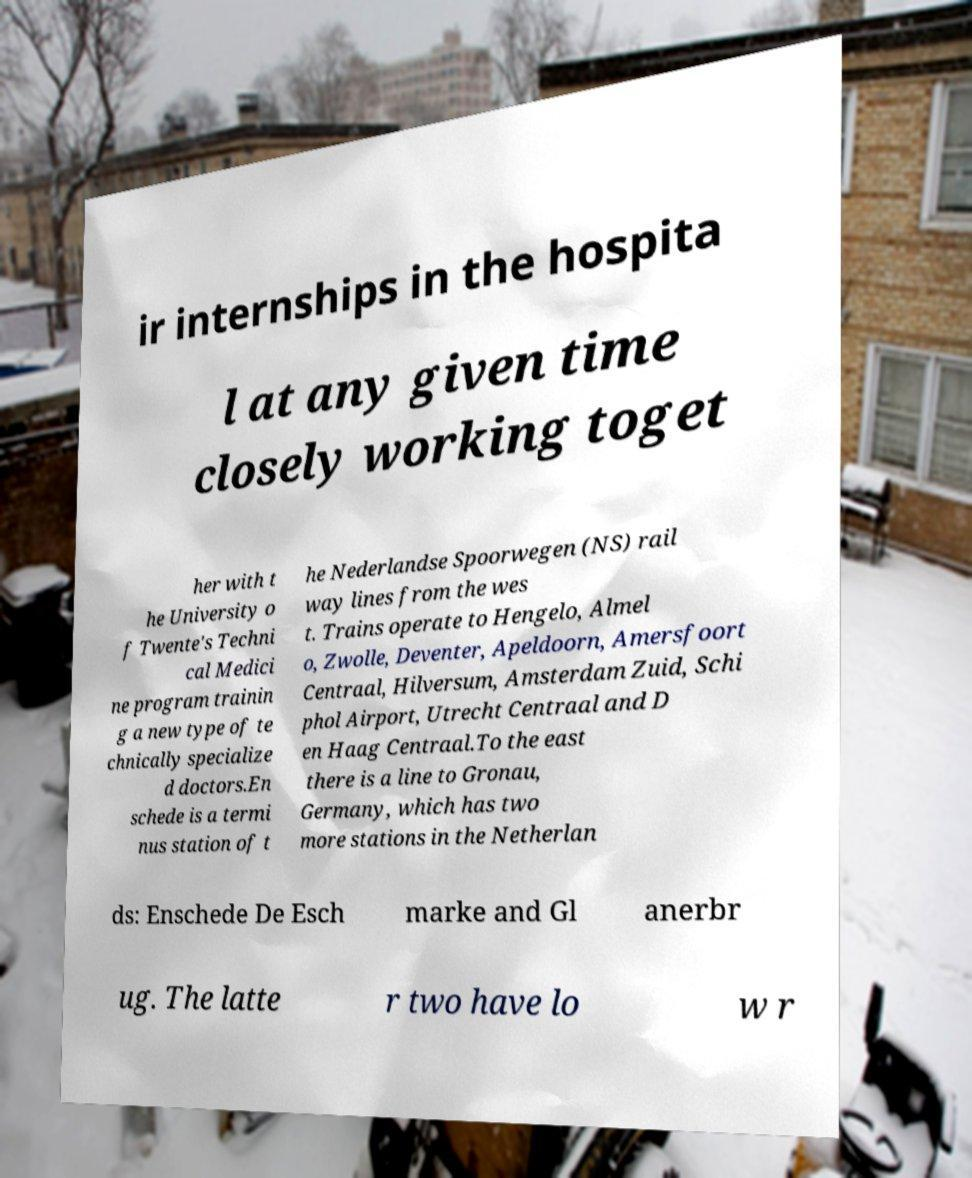Can you read and provide the text displayed in the image?This photo seems to have some interesting text. Can you extract and type it out for me? ir internships in the hospita l at any given time closely working toget her with t he University o f Twente's Techni cal Medici ne program trainin g a new type of te chnically specialize d doctors.En schede is a termi nus station of t he Nederlandse Spoorwegen (NS) rail way lines from the wes t. Trains operate to Hengelo, Almel o, Zwolle, Deventer, Apeldoorn, Amersfoort Centraal, Hilversum, Amsterdam Zuid, Schi phol Airport, Utrecht Centraal and D en Haag Centraal.To the east there is a line to Gronau, Germany, which has two more stations in the Netherlan ds: Enschede De Esch marke and Gl anerbr ug. The latte r two have lo w r 